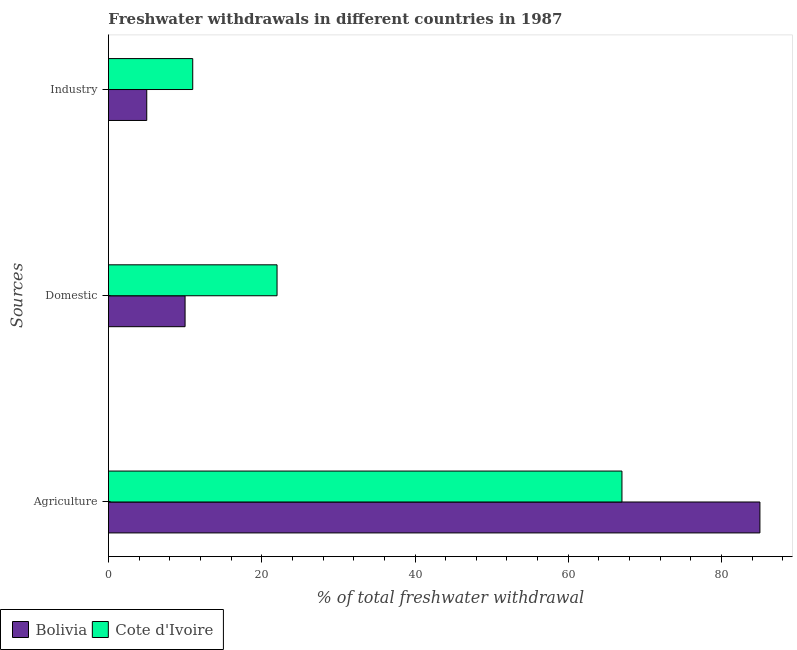How many different coloured bars are there?
Your answer should be very brief. 2. How many groups of bars are there?
Offer a terse response. 3. Are the number of bars per tick equal to the number of legend labels?
Offer a very short reply. Yes. Are the number of bars on each tick of the Y-axis equal?
Offer a terse response. Yes. How many bars are there on the 2nd tick from the bottom?
Offer a very short reply. 2. What is the label of the 3rd group of bars from the top?
Provide a succinct answer. Agriculture. What is the percentage of freshwater withdrawal for agriculture in Bolivia?
Offer a terse response. 85. Across all countries, what is the maximum percentage of freshwater withdrawal for agriculture?
Ensure brevity in your answer.  85. Across all countries, what is the minimum percentage of freshwater withdrawal for domestic purposes?
Offer a very short reply. 10. In which country was the percentage of freshwater withdrawal for domestic purposes maximum?
Ensure brevity in your answer.  Cote d'Ivoire. In which country was the percentage of freshwater withdrawal for industry minimum?
Offer a terse response. Bolivia. What is the total percentage of freshwater withdrawal for agriculture in the graph?
Your response must be concise. 152. What is the difference between the percentage of freshwater withdrawal for agriculture in Cote d'Ivoire and that in Bolivia?
Offer a terse response. -18. What is the difference between the percentage of freshwater withdrawal for domestic purposes in Cote d'Ivoire and the percentage of freshwater withdrawal for agriculture in Bolivia?
Offer a very short reply. -63. What is the difference between the percentage of freshwater withdrawal for domestic purposes and percentage of freshwater withdrawal for agriculture in Bolivia?
Ensure brevity in your answer.  -75. What is the ratio of the percentage of freshwater withdrawal for industry in Bolivia to that in Cote d'Ivoire?
Provide a short and direct response. 0.45. Is the percentage of freshwater withdrawal for industry in Bolivia less than that in Cote d'Ivoire?
Offer a very short reply. Yes. What is the difference between the highest and the second highest percentage of freshwater withdrawal for agriculture?
Provide a succinct answer. 18. What is the difference between the highest and the lowest percentage of freshwater withdrawal for domestic purposes?
Your answer should be very brief. 12. In how many countries, is the percentage of freshwater withdrawal for domestic purposes greater than the average percentage of freshwater withdrawal for domestic purposes taken over all countries?
Offer a very short reply. 1. Is the sum of the percentage of freshwater withdrawal for agriculture in Bolivia and Cote d'Ivoire greater than the maximum percentage of freshwater withdrawal for industry across all countries?
Your answer should be very brief. Yes. What does the 2nd bar from the top in Industry represents?
Ensure brevity in your answer.  Bolivia. Is it the case that in every country, the sum of the percentage of freshwater withdrawal for agriculture and percentage of freshwater withdrawal for domestic purposes is greater than the percentage of freshwater withdrawal for industry?
Your answer should be compact. Yes. How many bars are there?
Provide a succinct answer. 6. What is the difference between two consecutive major ticks on the X-axis?
Your response must be concise. 20. Are the values on the major ticks of X-axis written in scientific E-notation?
Your answer should be compact. No. What is the title of the graph?
Your response must be concise. Freshwater withdrawals in different countries in 1987. What is the label or title of the X-axis?
Give a very brief answer. % of total freshwater withdrawal. What is the label or title of the Y-axis?
Make the answer very short. Sources. What is the % of total freshwater withdrawal of Bolivia in Agriculture?
Offer a very short reply. 85. What is the % of total freshwater withdrawal of Cote d'Ivoire in Agriculture?
Provide a succinct answer. 67. What is the % of total freshwater withdrawal of Bolivia in Domestic?
Make the answer very short. 10. What is the % of total freshwater withdrawal in Cote d'Ivoire in Domestic?
Provide a succinct answer. 22. What is the % of total freshwater withdrawal in Cote d'Ivoire in Industry?
Your response must be concise. 11. Across all Sources, what is the maximum % of total freshwater withdrawal in Bolivia?
Your answer should be compact. 85. Across all Sources, what is the minimum % of total freshwater withdrawal of Bolivia?
Give a very brief answer. 5. Across all Sources, what is the minimum % of total freshwater withdrawal in Cote d'Ivoire?
Your answer should be compact. 11. What is the difference between the % of total freshwater withdrawal in Cote d'Ivoire in Agriculture and that in Domestic?
Make the answer very short. 45. What is the difference between the % of total freshwater withdrawal in Cote d'Ivoire in Agriculture and that in Industry?
Your answer should be very brief. 56. What is the difference between the % of total freshwater withdrawal in Bolivia in Agriculture and the % of total freshwater withdrawal in Cote d'Ivoire in Industry?
Give a very brief answer. 74. What is the average % of total freshwater withdrawal of Bolivia per Sources?
Make the answer very short. 33.33. What is the average % of total freshwater withdrawal of Cote d'Ivoire per Sources?
Provide a short and direct response. 33.33. What is the difference between the % of total freshwater withdrawal of Bolivia and % of total freshwater withdrawal of Cote d'Ivoire in Agriculture?
Give a very brief answer. 18. What is the difference between the % of total freshwater withdrawal in Bolivia and % of total freshwater withdrawal in Cote d'Ivoire in Industry?
Your answer should be compact. -6. What is the ratio of the % of total freshwater withdrawal of Cote d'Ivoire in Agriculture to that in Domestic?
Ensure brevity in your answer.  3.05. What is the ratio of the % of total freshwater withdrawal in Bolivia in Agriculture to that in Industry?
Offer a terse response. 17. What is the ratio of the % of total freshwater withdrawal in Cote d'Ivoire in Agriculture to that in Industry?
Provide a short and direct response. 6.09. What is the ratio of the % of total freshwater withdrawal of Cote d'Ivoire in Domestic to that in Industry?
Your answer should be very brief. 2. What is the difference between the highest and the lowest % of total freshwater withdrawal in Bolivia?
Offer a terse response. 80. 